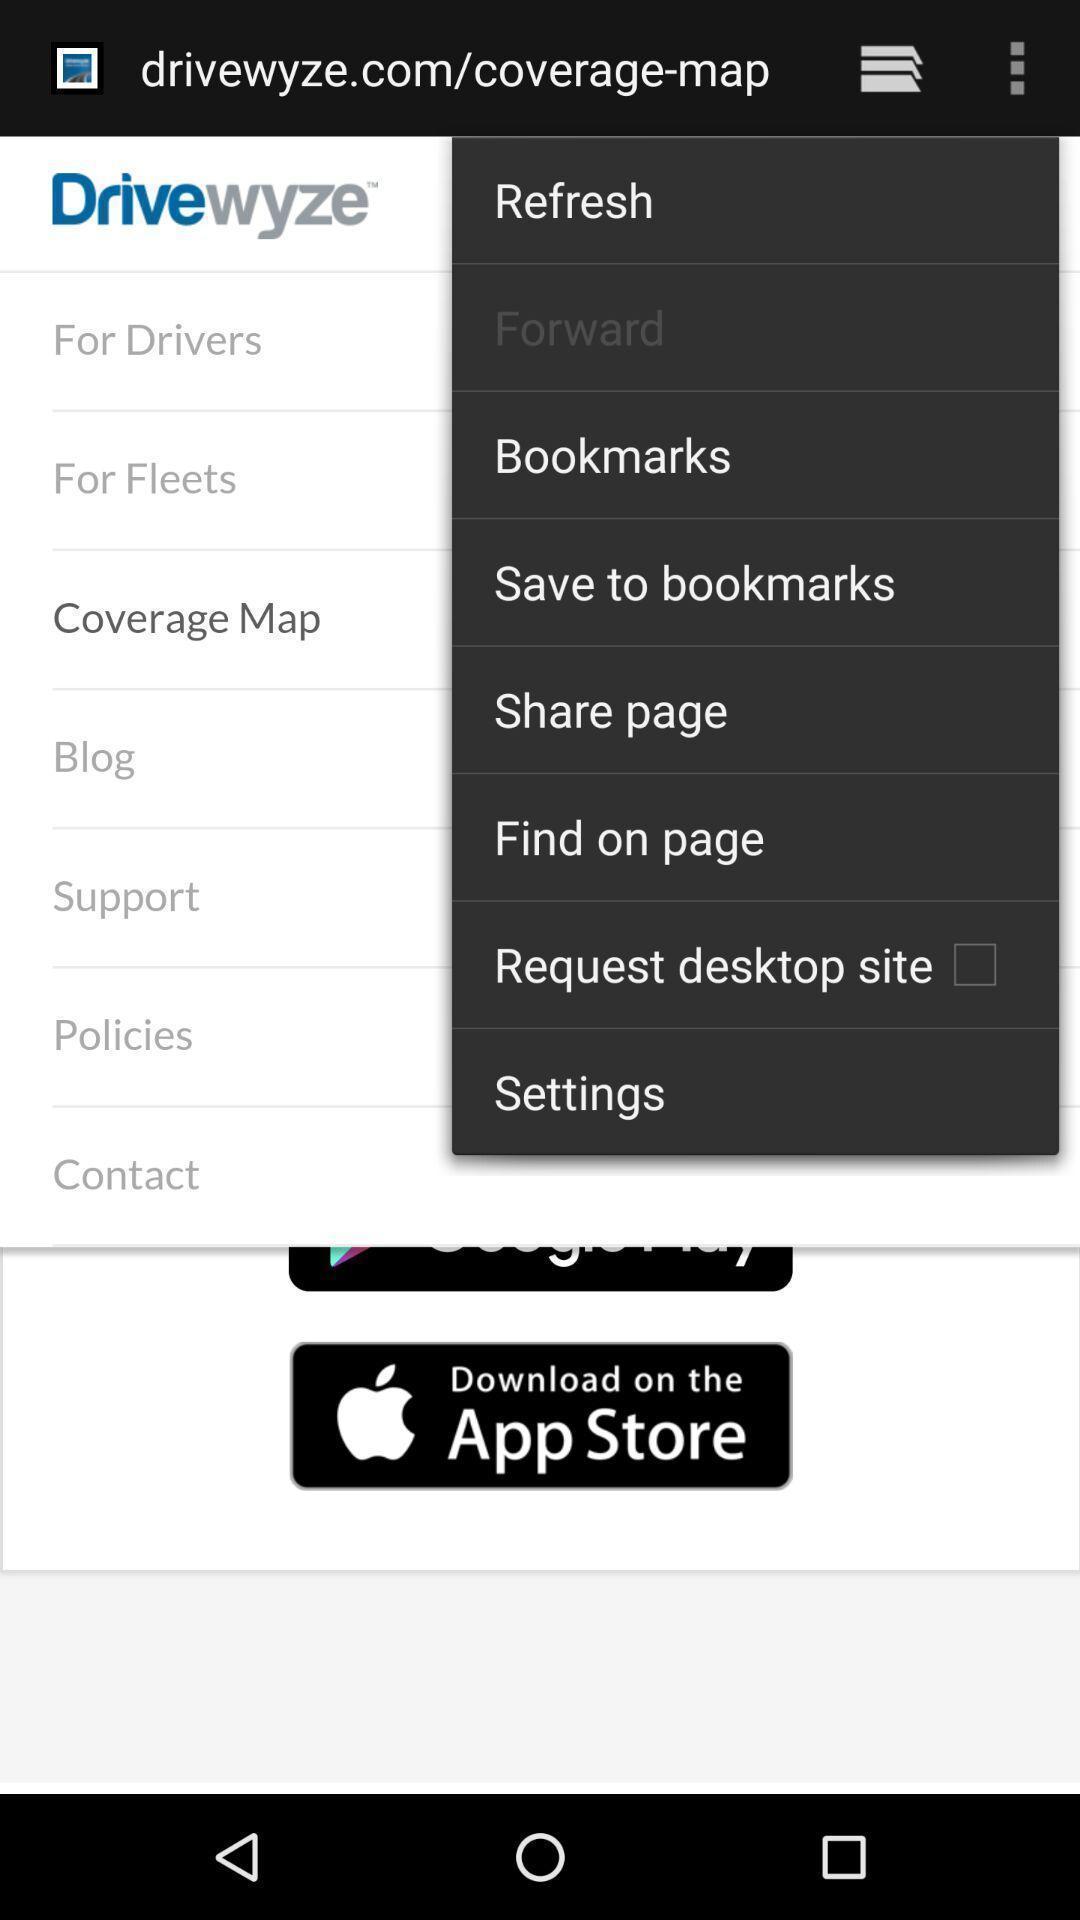What details can you identify in this image? Window displaying trucker app for drivers. 